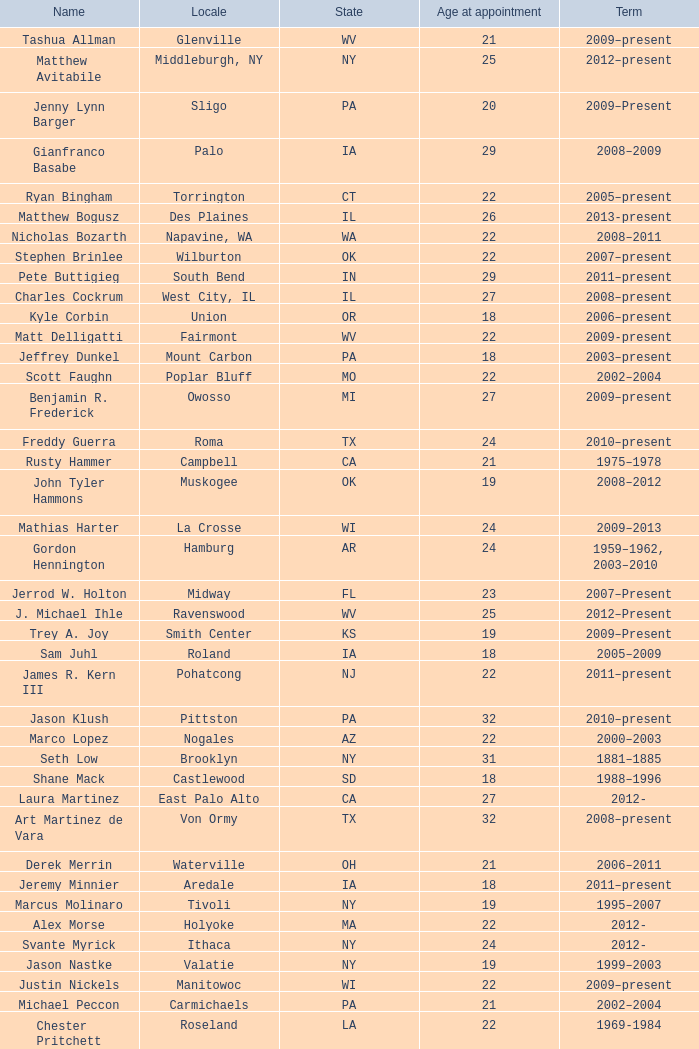What is the denomination of the netherlands area? Philip A. Tanis. 